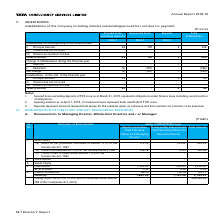According to Tata Consultancy Services's financial document, What was the value of deposits as at March 31, 2019? Based on the financial document, the answer is `39 crore. Also, What are deposits? amounts received from lessee for the premises given on sub-lease and from vendors for contracts to be executed.. The document states: "nk overdraft of ` 181 crore. 3. Deposits represent amounts received from lessee for the premises given on sub-lease and from vendors for contracts to ..." Also, What is the value of the bank overdraft as at April 1, 2018? Based on the financial document, the answer is `181 crore. Also, can you calculate: At the beginning of the financial year, what percentage of total indebtedness is made up of deposits? Based on the calculation: 3/228 , the result is 1.32 (percentage). This is based on the information: "of the financial year i) Principal Amount 44 181 3 228 ii) Interest due but not paid - - - - iii) Interest accrued but not due - - - - Total (i+ii+iii f the financial year i) Principal Amount 44 181 3..." The key data points involved are: 228. Also, can you calculate: What is the change in total indebtedness between the beginning and end of the financial year? Based on the calculation: 43-228, the result is -185. This is based on the information: "of the financial year i) Principal amount 39 - 4 43 ii) Interest due but not paid - - - - iii) Interest accrued but not due - - - - Total (i+ii+iii) 39 f the financial year i) Principal Amount 44 181 ..." The key data points involved are: 228, 43. Also, can you calculate: At the beginning of the financial year, what percentage of total indebtedness is made up of unsecured loans? Based on the calculation: 181/228, the result is 79.39 (percentage). This is based on the information: "ning of the financial year i) Principal Amount 44 181 3 228 ii) Interest due but not paid - - - - iii) Interest accrued but not due - - - - Total (i+ii+i f the financial year i) Principal Amount 44 18..." The key data points involved are: 181, 228. 